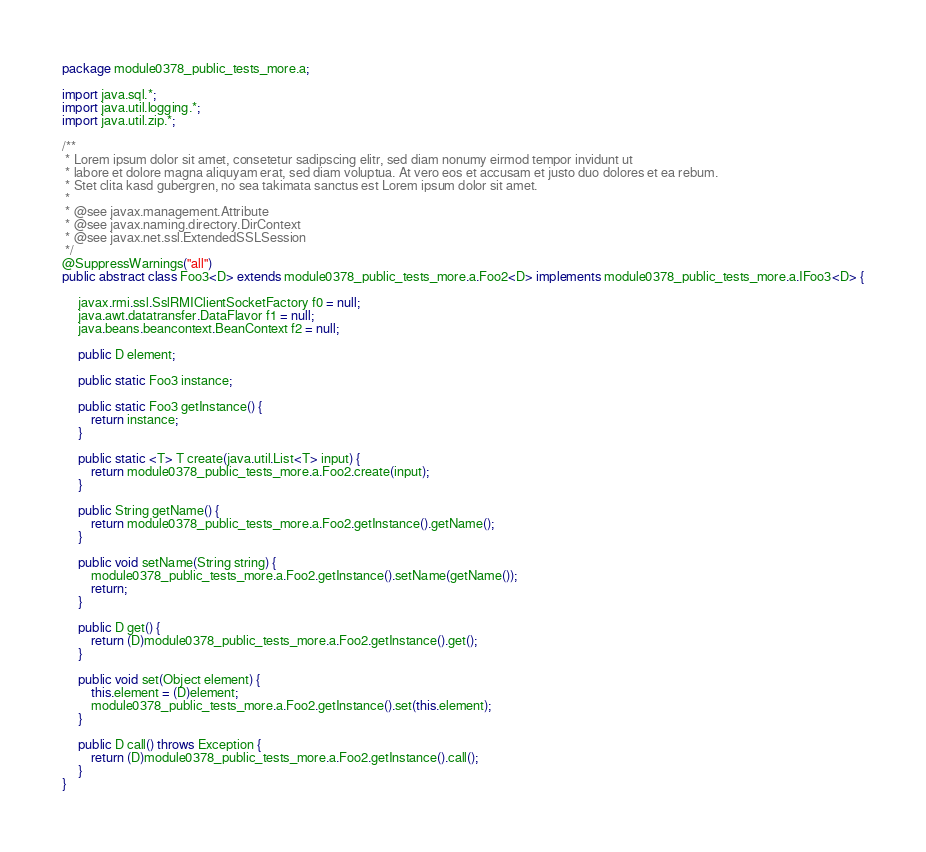Convert code to text. <code><loc_0><loc_0><loc_500><loc_500><_Java_>package module0378_public_tests_more.a;

import java.sql.*;
import java.util.logging.*;
import java.util.zip.*;

/**
 * Lorem ipsum dolor sit amet, consetetur sadipscing elitr, sed diam nonumy eirmod tempor invidunt ut 
 * labore et dolore magna aliquyam erat, sed diam voluptua. At vero eos et accusam et justo duo dolores et ea rebum. 
 * Stet clita kasd gubergren, no sea takimata sanctus est Lorem ipsum dolor sit amet. 
 *
 * @see javax.management.Attribute
 * @see javax.naming.directory.DirContext
 * @see javax.net.ssl.ExtendedSSLSession
 */
@SuppressWarnings("all")
public abstract class Foo3<D> extends module0378_public_tests_more.a.Foo2<D> implements module0378_public_tests_more.a.IFoo3<D> {

	 javax.rmi.ssl.SslRMIClientSocketFactory f0 = null;
	 java.awt.datatransfer.DataFlavor f1 = null;
	 java.beans.beancontext.BeanContext f2 = null;

	 public D element;

	 public static Foo3 instance;

	 public static Foo3 getInstance() {
	 	 return instance;
	 }

	 public static <T> T create(java.util.List<T> input) {
	 	 return module0378_public_tests_more.a.Foo2.create(input);
	 }

	 public String getName() {
	 	 return module0378_public_tests_more.a.Foo2.getInstance().getName();
	 }

	 public void setName(String string) {
	 	 module0378_public_tests_more.a.Foo2.getInstance().setName(getName());
	 	 return;
	 }

	 public D get() {
	 	 return (D)module0378_public_tests_more.a.Foo2.getInstance().get();
	 }

	 public void set(Object element) {
	 	 this.element = (D)element;
	 	 module0378_public_tests_more.a.Foo2.getInstance().set(this.element);
	 }

	 public D call() throws Exception {
	 	 return (D)module0378_public_tests_more.a.Foo2.getInstance().call();
	 }
}
</code> 